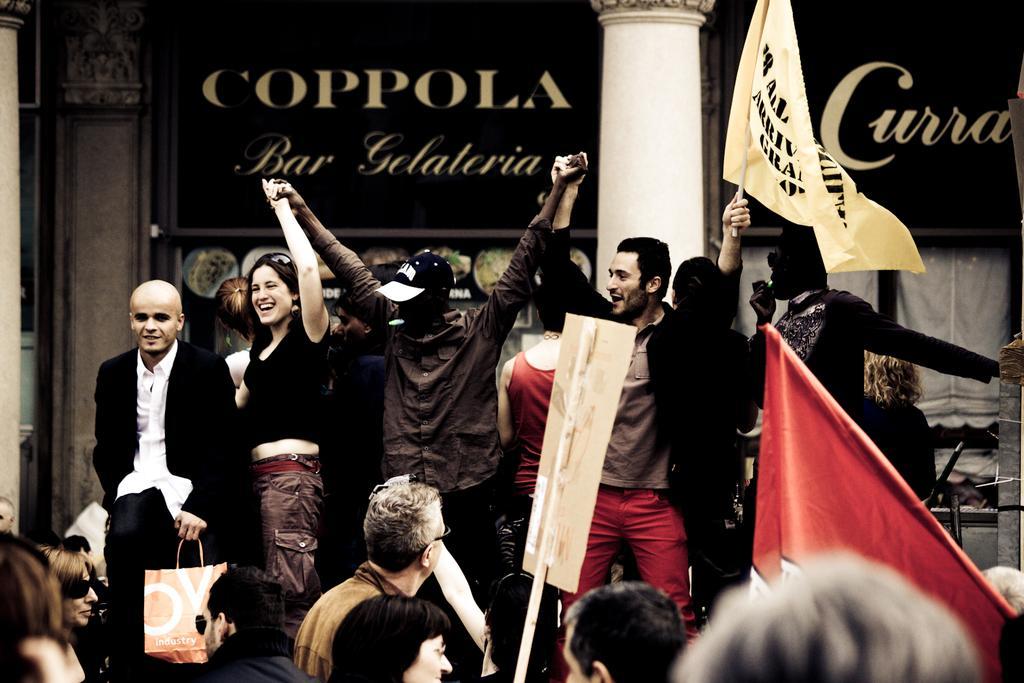Describe this image in one or two sentences. In this image there are people standing few are holding flags in their hands and few are holding posters, in the background there are pillars and a wall for that wall there is a board, on that board there is text. 